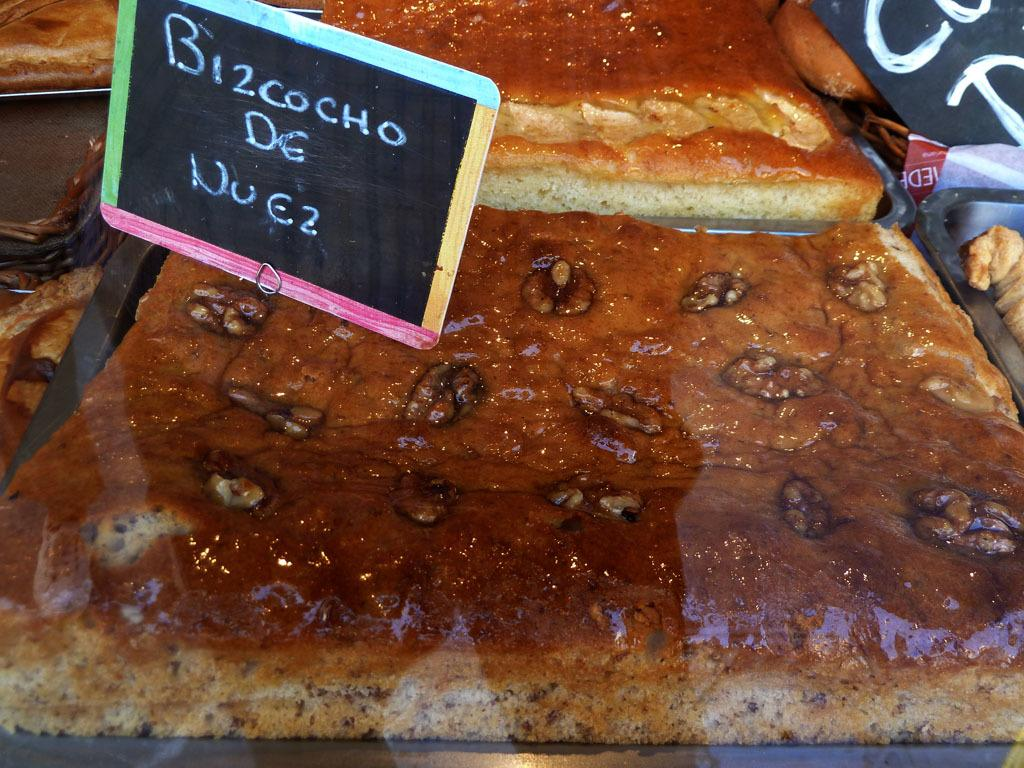What type of food can be seen on the trays in the image? There are cakes on trays in the image. What else is present in the image besides the cakes? There is a board with text in the image. How many people are reciting a verse in the image? There is no indication of people reciting a verse in the image; it only features cakes on trays and a board with text. 